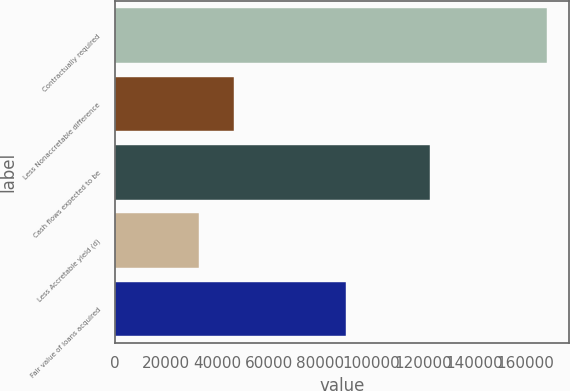Convert chart to OTSL. <chart><loc_0><loc_0><loc_500><loc_500><bar_chart><fcel>Contractually required<fcel>Less Nonaccretable difference<fcel>Cash flows expected to be<fcel>Less Accretable yield (d)<fcel>Fair value of loans acquired<nl><fcel>168460<fcel>46241.8<fcel>122770<fcel>32662<fcel>90108<nl></chart> 